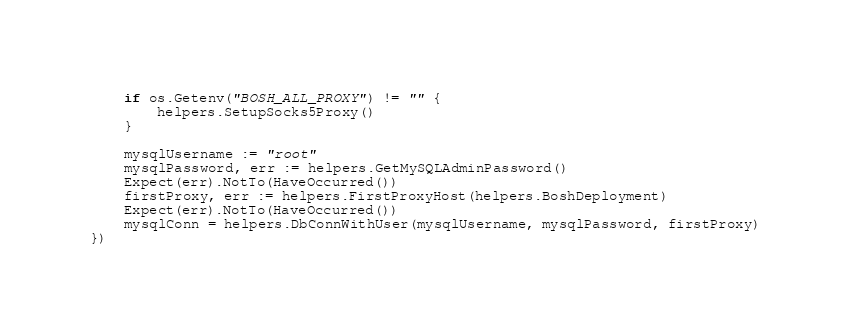Convert code to text. <code><loc_0><loc_0><loc_500><loc_500><_Go_>	if os.Getenv("BOSH_ALL_PROXY") != "" {
		helpers.SetupSocks5Proxy()
	}

	mysqlUsername := "root"
	mysqlPassword, err := helpers.GetMySQLAdminPassword()
	Expect(err).NotTo(HaveOccurred())
	firstProxy, err := helpers.FirstProxyHost(helpers.BoshDeployment)
	Expect(err).NotTo(HaveOccurred())
	mysqlConn = helpers.DbConnWithUser(mysqlUsername, mysqlPassword, firstProxy)
})
</code> 